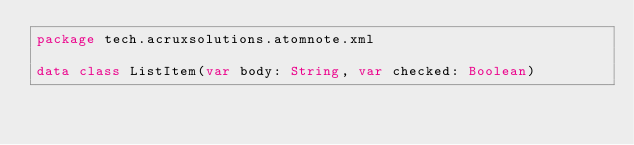<code> <loc_0><loc_0><loc_500><loc_500><_Kotlin_>package tech.acruxsolutions.atomnote.xml

data class ListItem(var body: String, var checked: Boolean)</code> 